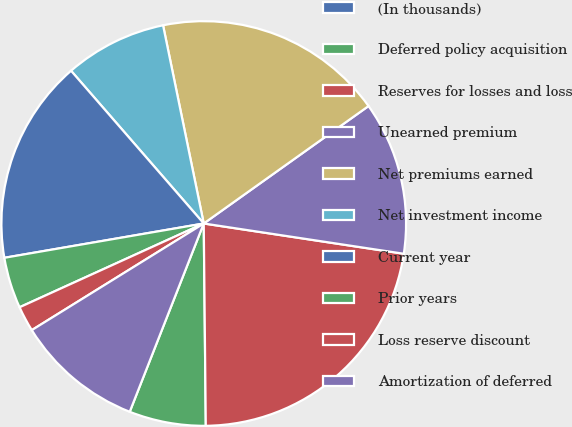Convert chart. <chart><loc_0><loc_0><loc_500><loc_500><pie_chart><fcel>(In thousands)<fcel>Deferred policy acquisition<fcel>Reserves for losses and loss<fcel>Unearned premium<fcel>Net premiums earned<fcel>Net investment income<fcel>Current year<fcel>Prior years<fcel>Loss reserve discount<fcel>Amortization of deferred<nl><fcel>0.0%<fcel>6.12%<fcel>22.44%<fcel>12.24%<fcel>18.36%<fcel>8.16%<fcel>16.32%<fcel>4.08%<fcel>2.04%<fcel>10.2%<nl></chart> 